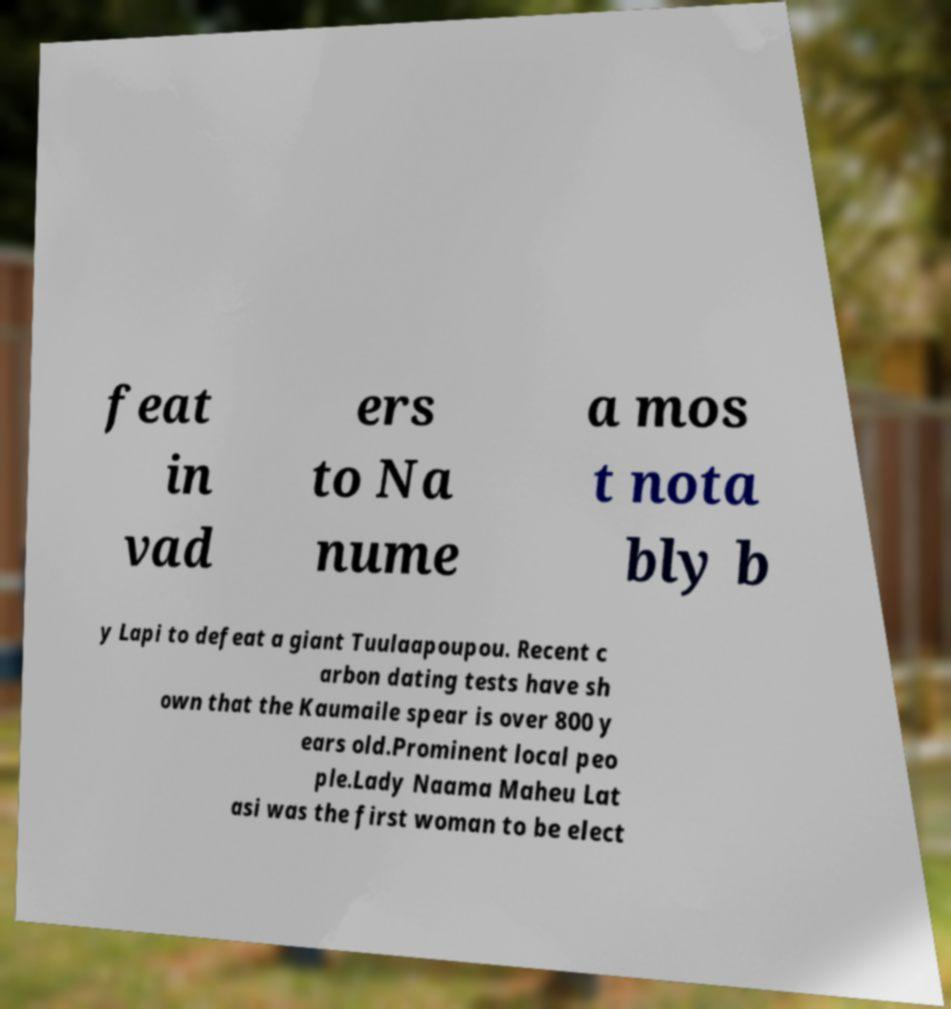What messages or text are displayed in this image? I need them in a readable, typed format. feat in vad ers to Na nume a mos t nota bly b y Lapi to defeat a giant Tuulaapoupou. Recent c arbon dating tests have sh own that the Kaumaile spear is over 800 y ears old.Prominent local peo ple.Lady Naama Maheu Lat asi was the first woman to be elect 